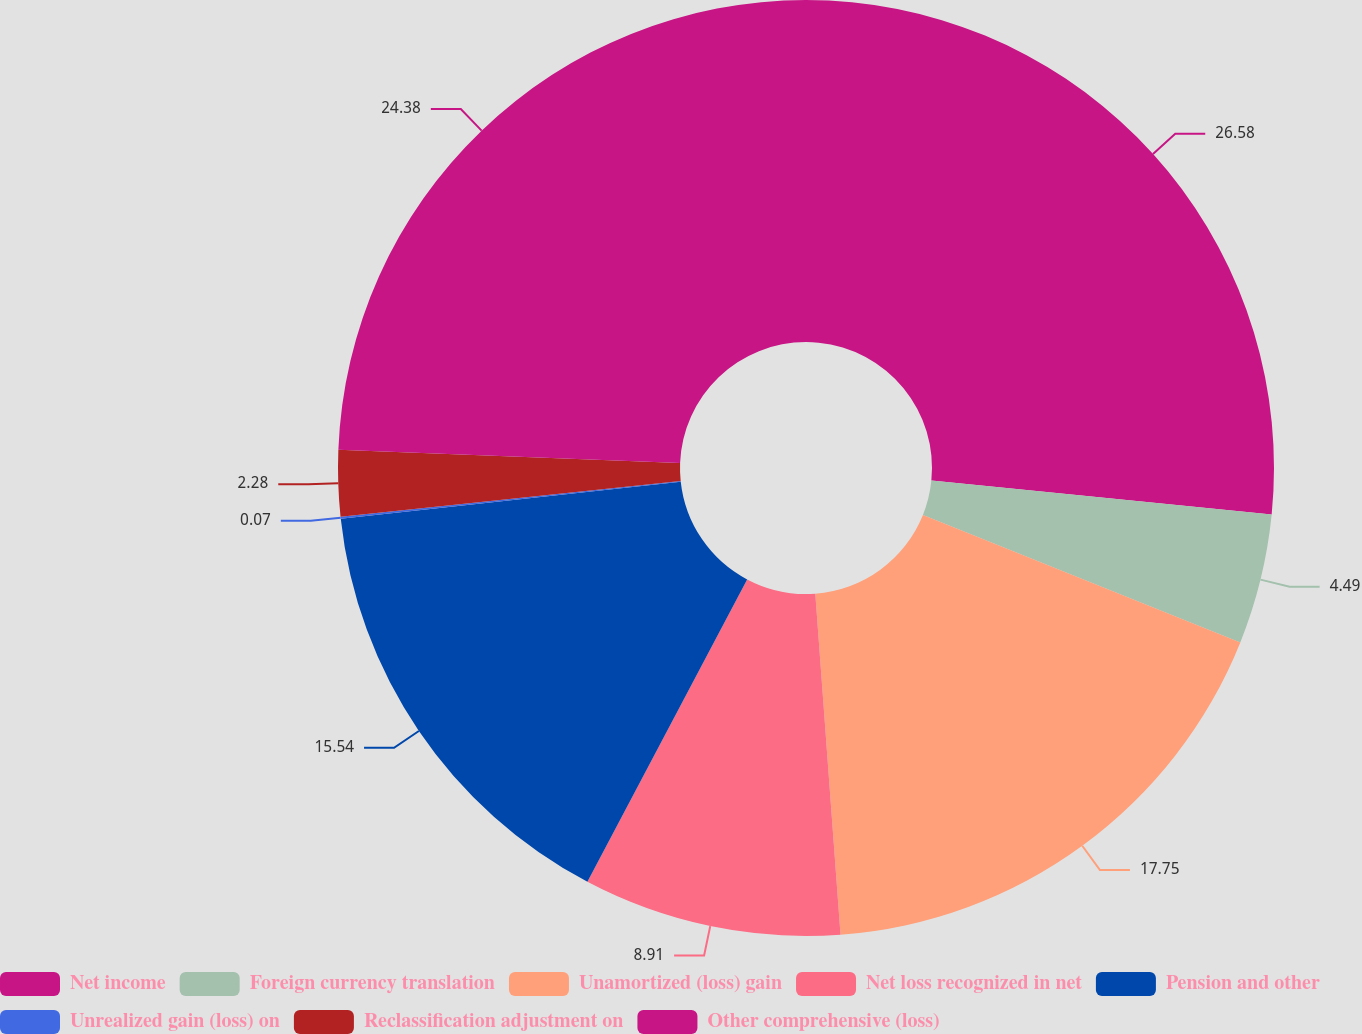Convert chart. <chart><loc_0><loc_0><loc_500><loc_500><pie_chart><fcel>Net income<fcel>Foreign currency translation<fcel>Unamortized (loss) gain<fcel>Net loss recognized in net<fcel>Pension and other<fcel>Unrealized gain (loss) on<fcel>Reclassification adjustment on<fcel>Other comprehensive (loss)<nl><fcel>26.59%<fcel>4.49%<fcel>17.75%<fcel>8.91%<fcel>15.54%<fcel>0.07%<fcel>2.28%<fcel>24.38%<nl></chart> 